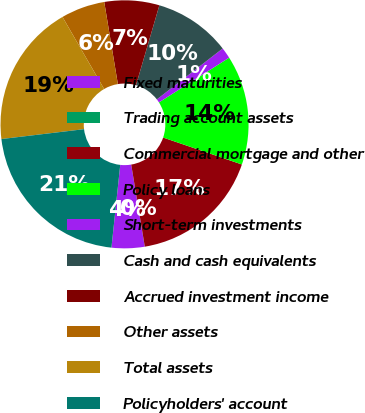<chart> <loc_0><loc_0><loc_500><loc_500><pie_chart><fcel>Fixed maturities<fcel>Trading account assets<fcel>Commercial mortgage and other<fcel>Policy loans<fcel>Short-term investments<fcel>Cash and cash equivalents<fcel>Accrued investment income<fcel>Other assets<fcel>Total assets<fcel>Policyholders' account<nl><fcel>4.29%<fcel>0.01%<fcel>17.14%<fcel>14.28%<fcel>1.44%<fcel>10.0%<fcel>7.15%<fcel>5.72%<fcel>18.56%<fcel>21.42%<nl></chart> 